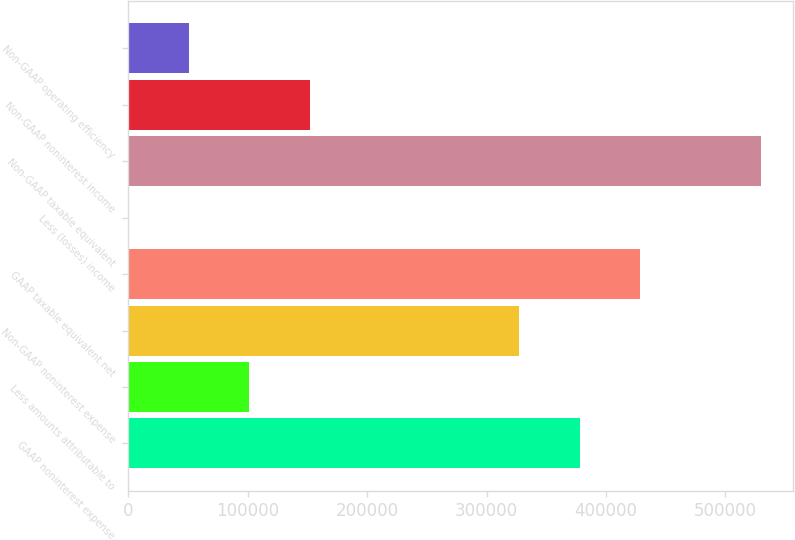Convert chart. <chart><loc_0><loc_0><loc_500><loc_500><bar_chart><fcel>GAAP noninterest expense<fcel>Less amounts attributable to<fcel>Non-GAAP noninterest expense<fcel>GAAP taxable equivalent net<fcel>Less (losses) income<fcel>Non-GAAP taxable equivalent<fcel>Non-GAAP noninterest income<fcel>Non-GAAP operating efficiency<nl><fcel>378023<fcel>101418<fcel>327323<fcel>428723<fcel>18<fcel>530122<fcel>152117<fcel>50717.8<nl></chart> 